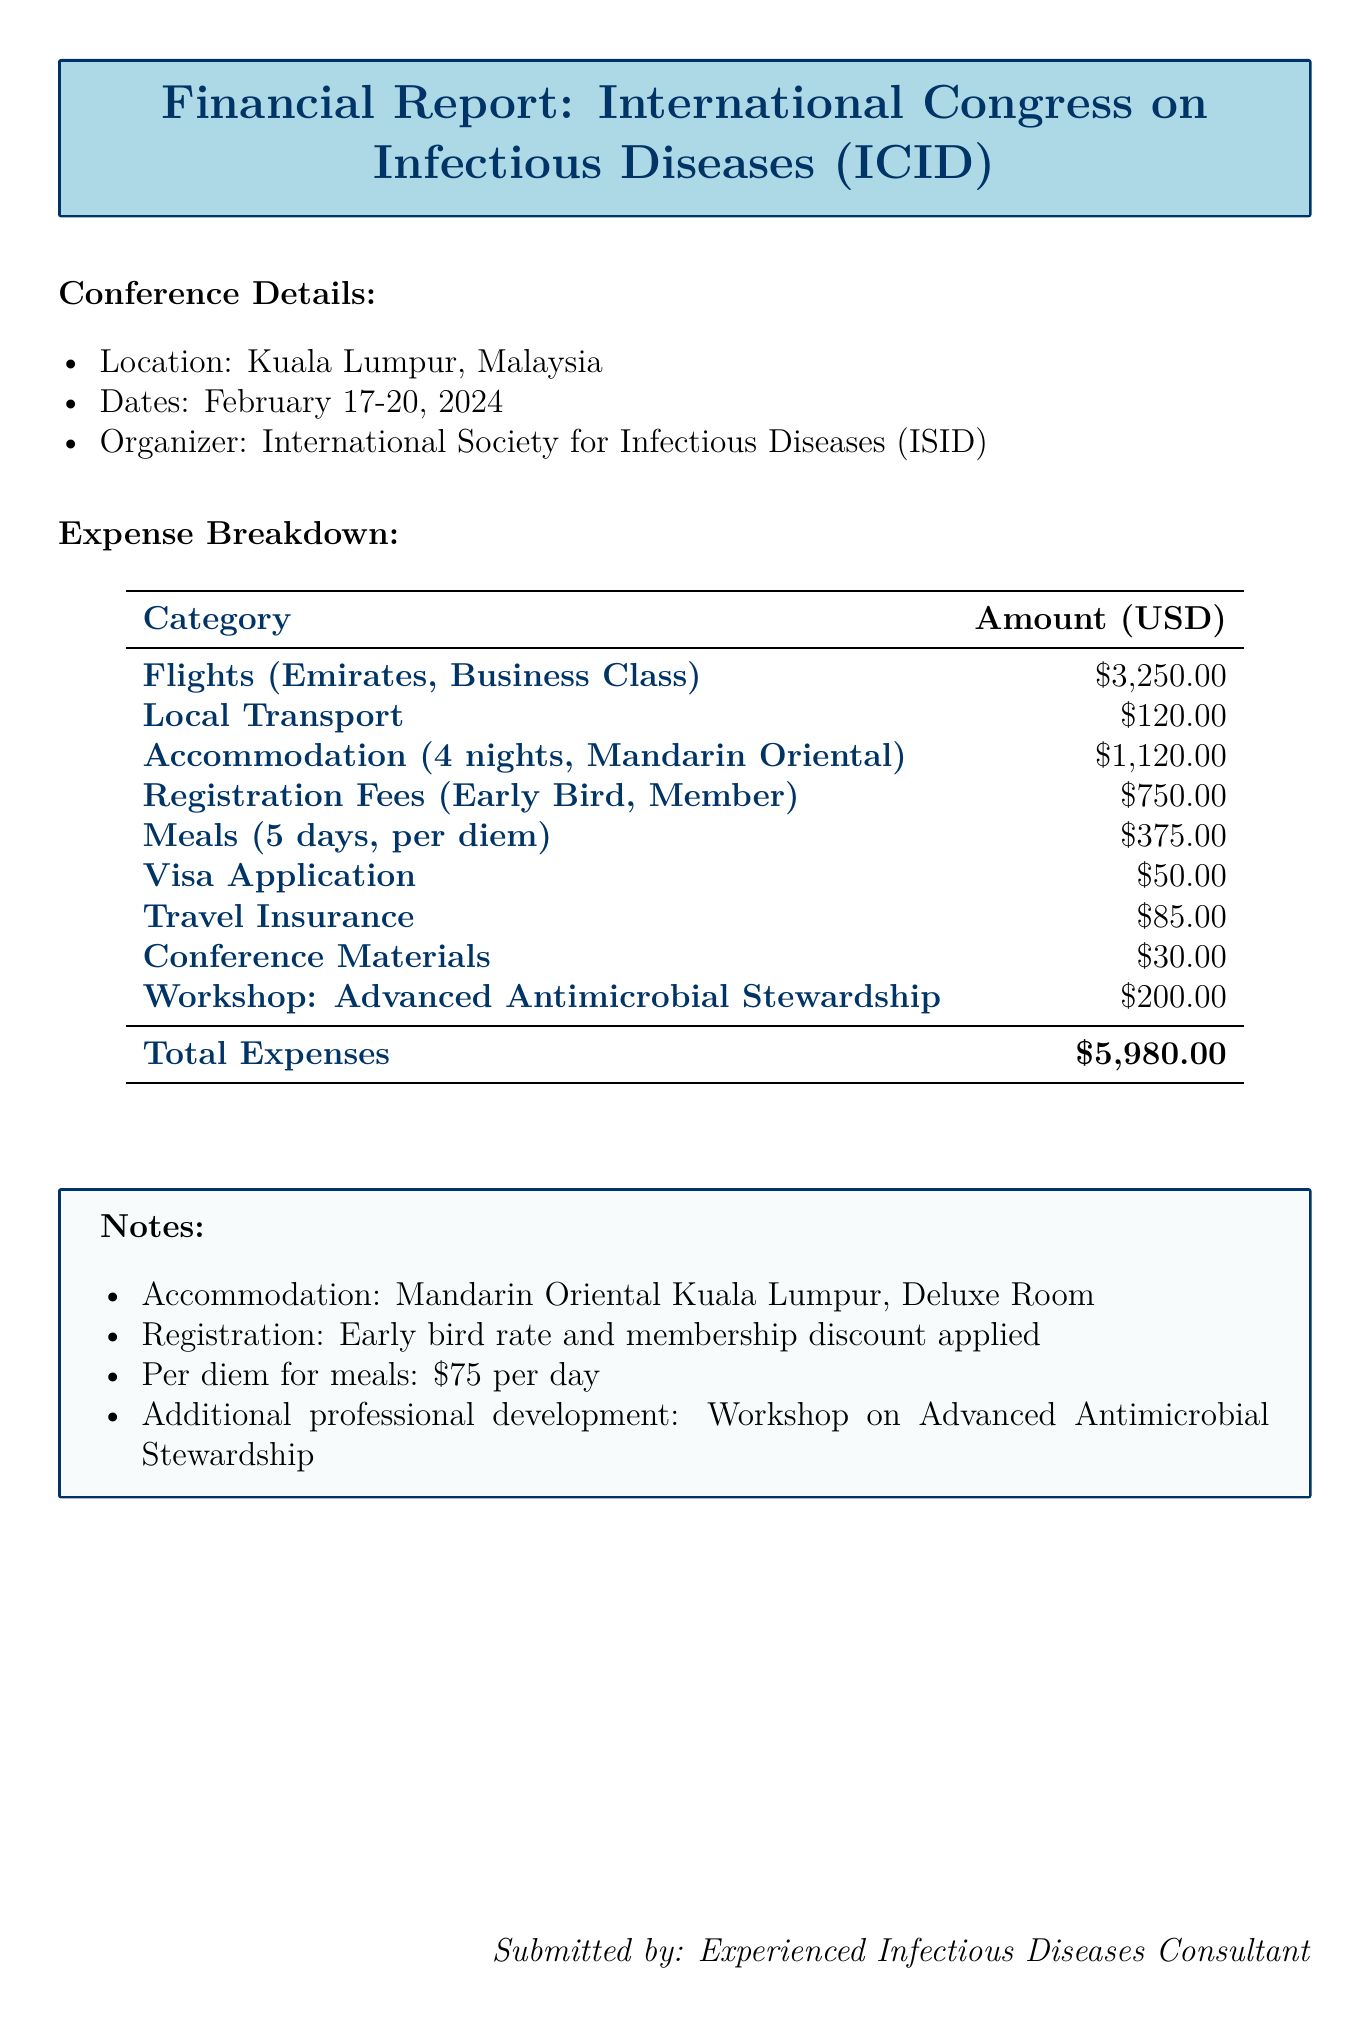What is the location of the conference? The document specifies that the conference takes place in Kuala Lumpur, Malaysia.
Answer: Kuala Lumpur, Malaysia What are the dates of the conference? The report indicates that the conference is held from February 17 to February 20, 2024.
Answer: February 17-20, 2024 What is the total cost for accommodation? The document lists the accommodation cost as $280 per night for 4 nights, totaling $1120.
Answer: $1120 What is the cost of the registration fees? The registration fees are noted as $750, which includes early bird and membership discounts.
Answer: $750 How much was spent on local transport? The report states that local transport expenses amounted to $120.
Answer: $120 What is the per diem amount for meals? The document describes the per diem for meals as $75 per day.
Answer: $75 What is the total expense reported for the conference? The total expenses, accumulated from various categories, amount to $5980.
Answer: $5980 Which workshop was attended for professional development? According to the document, the workshop attended was on Advanced Antimicrobial Stewardship.
Answer: Advanced Antimicrobial Stewardship How many nights was accommodation booked? The report specifies that accommodation was booked for 4 nights.
Answer: 4 nights 